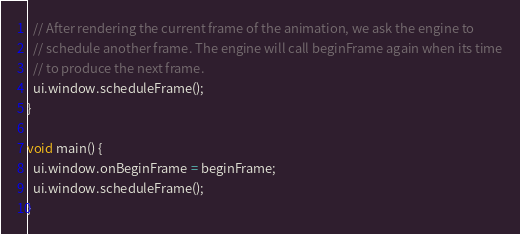Convert code to text. <code><loc_0><loc_0><loc_500><loc_500><_Dart_>
  // After rendering the current frame of the animation, we ask the engine to
  // schedule another frame. The engine will call beginFrame again when its time
  // to produce the next frame.
  ui.window.scheduleFrame();
}

void main() {
  ui.window.onBeginFrame = beginFrame;
  ui.window.scheduleFrame();
}
</code> 